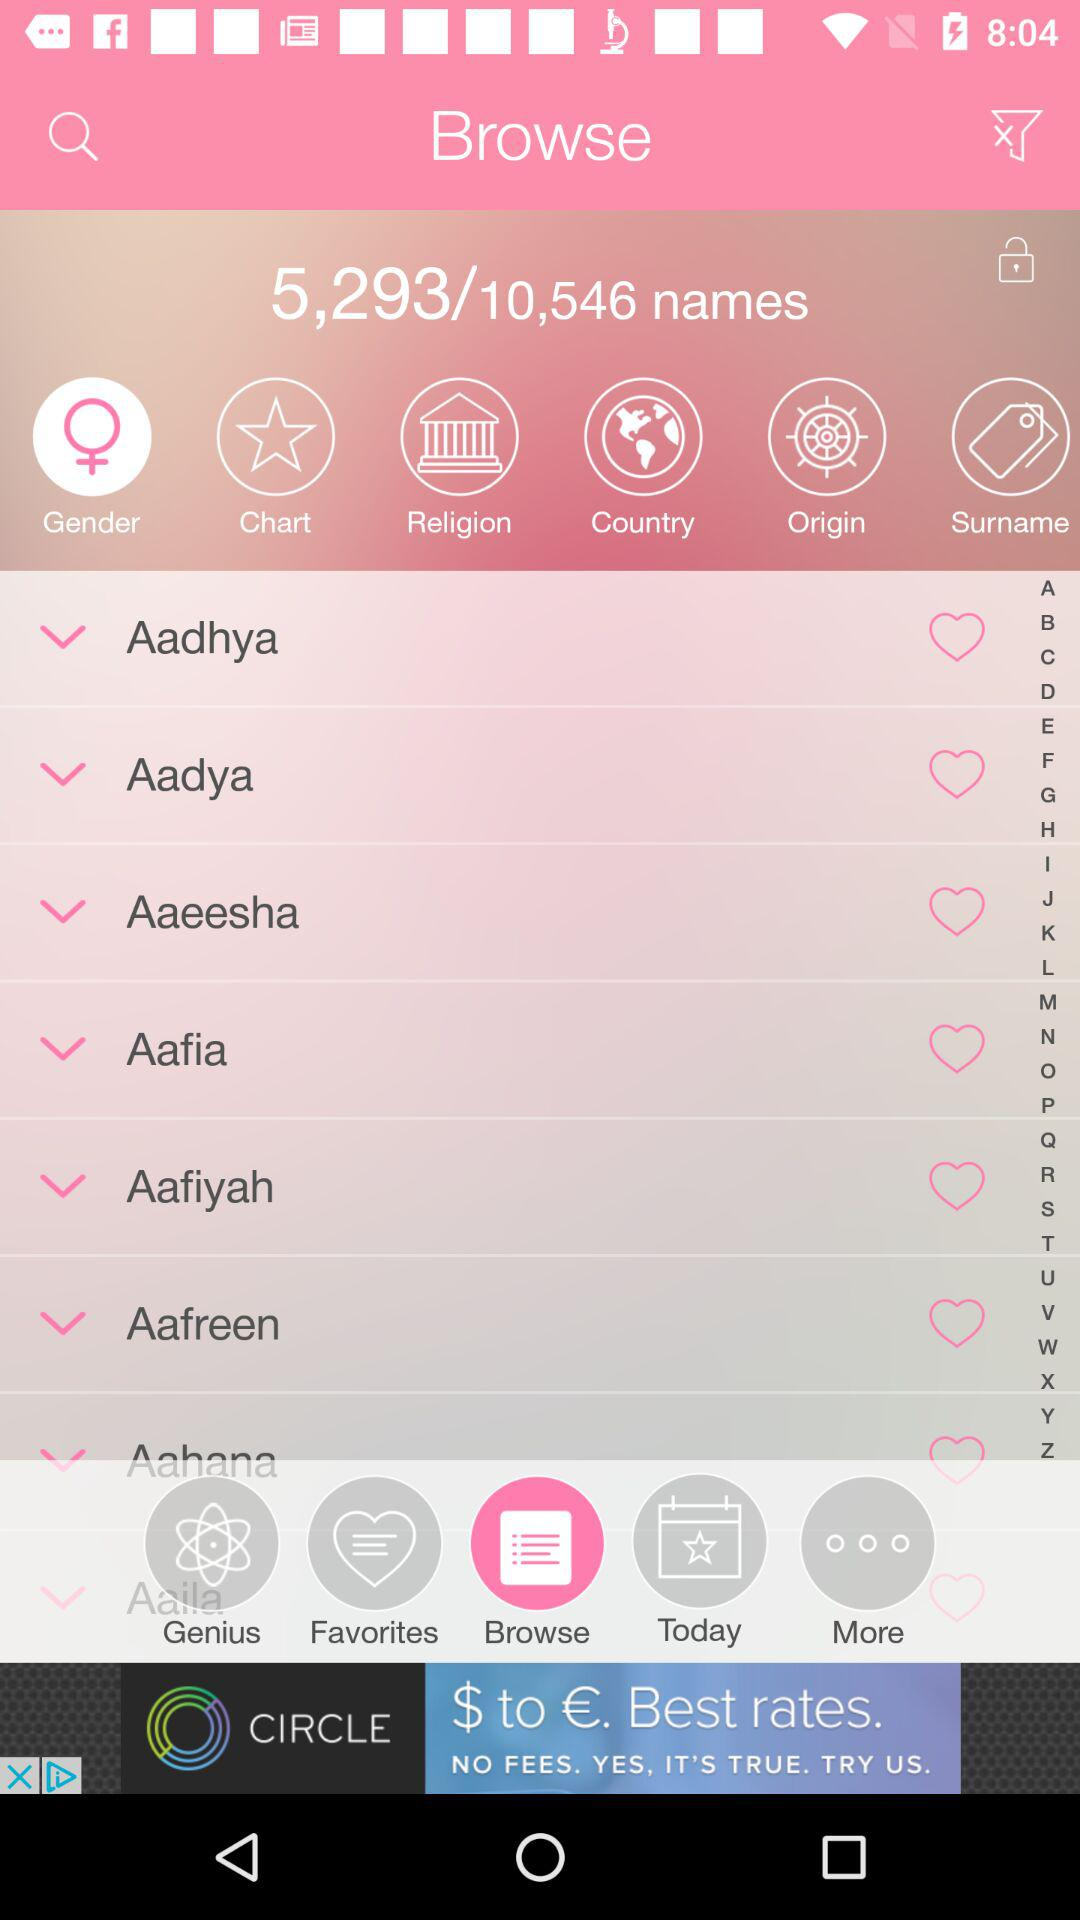On which number in the name list are we? In the name list, you are on 5,293 number. 